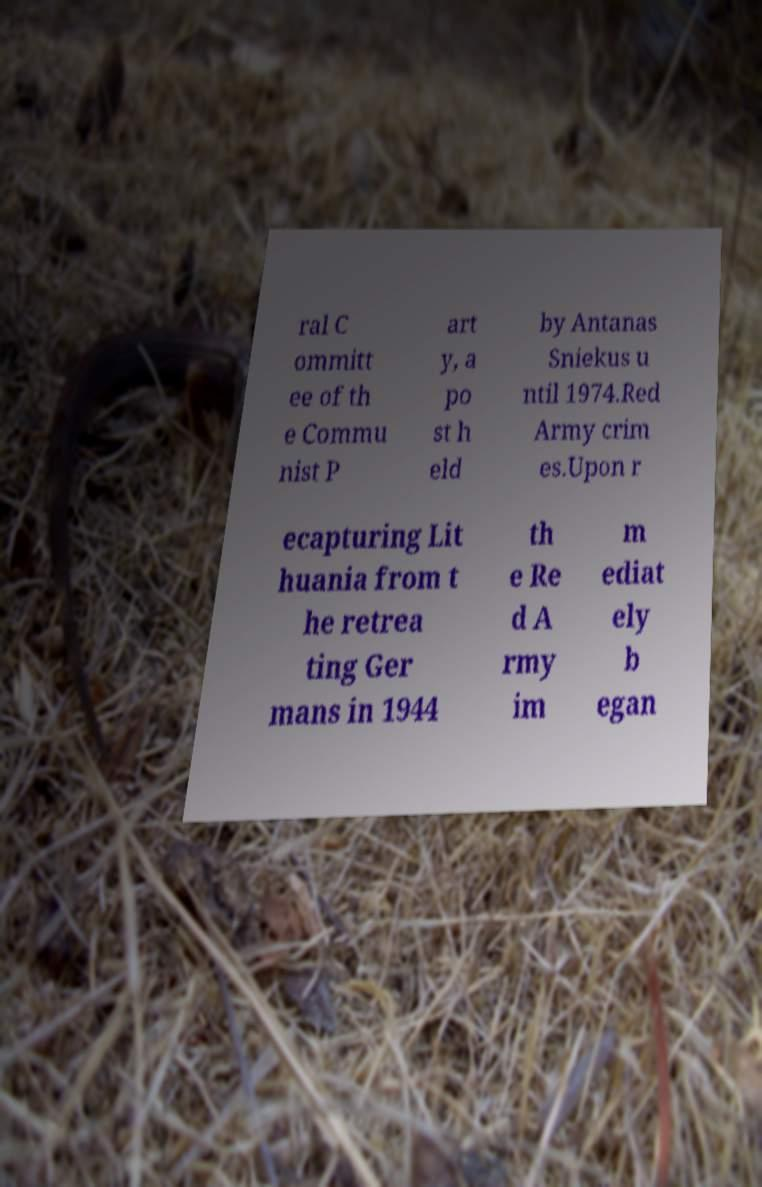Please read and relay the text visible in this image. What does it say? ral C ommitt ee of th e Commu nist P art y, a po st h eld by Antanas Sniekus u ntil 1974.Red Army crim es.Upon r ecapturing Lit huania from t he retrea ting Ger mans in 1944 th e Re d A rmy im m ediat ely b egan 